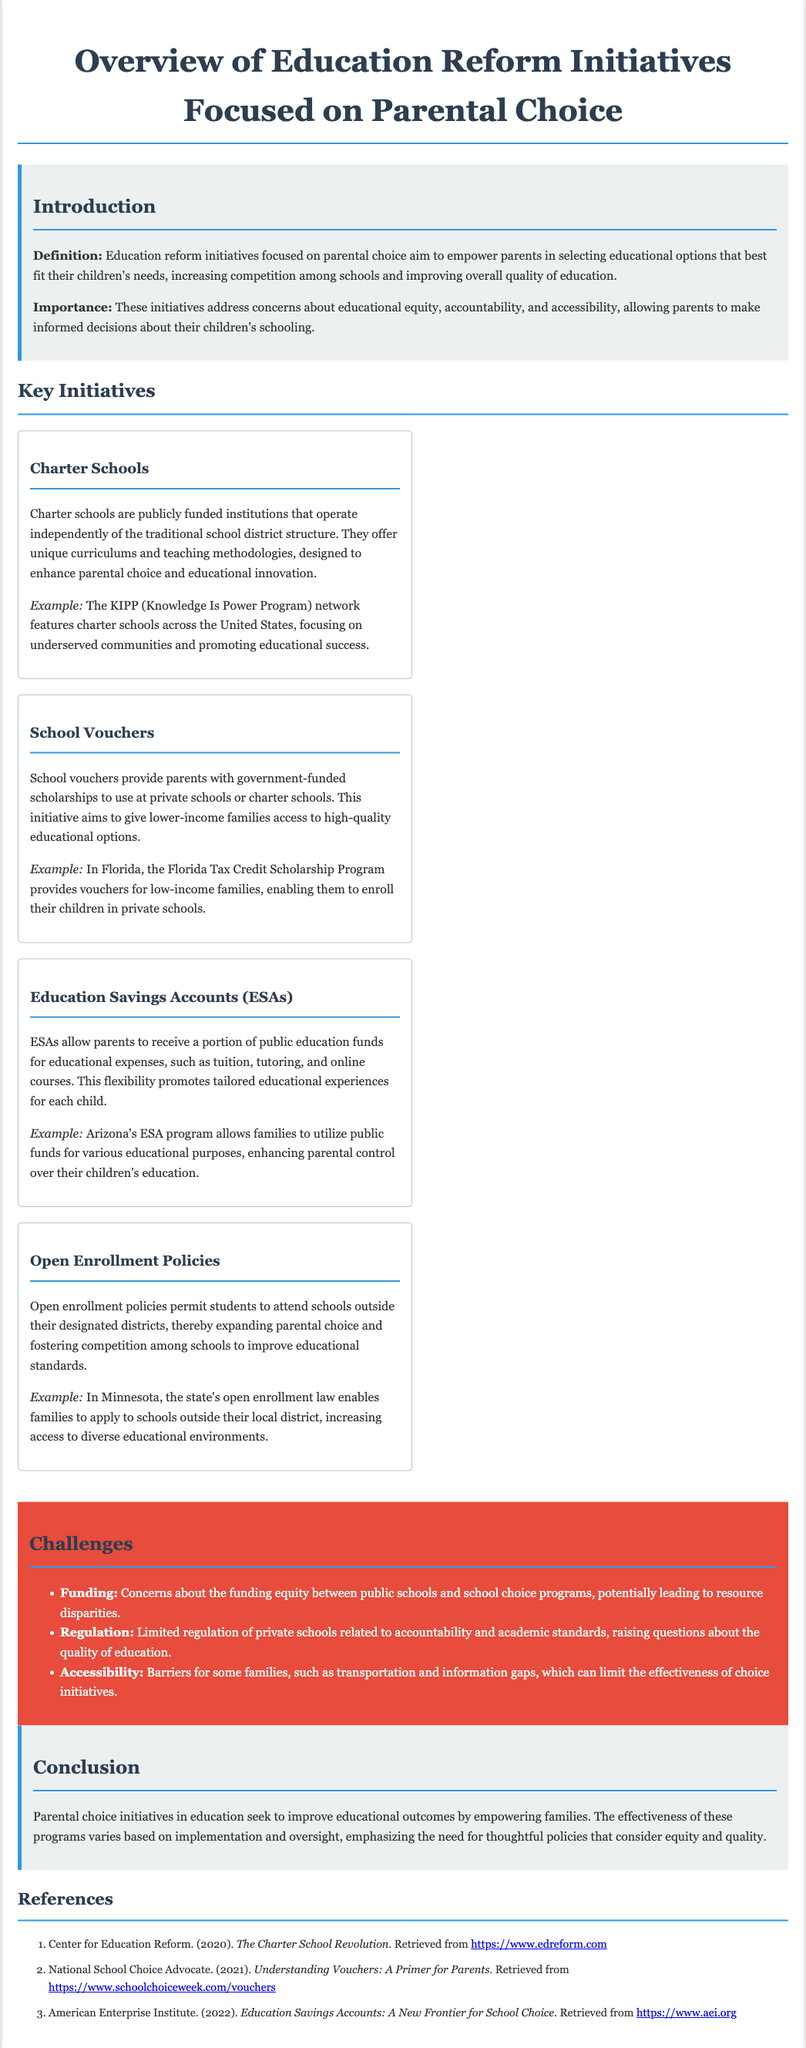what is the title of the document? The title is found in the <title> tag of the document.
Answer: Overview of Education Reform Initiatives Focused on Parental Choice what is the definition of education reform initiatives focused on parental choice? The definition is provided in the introduction section of the document.
Answer: Empower parents in selecting educational options what initiative provides government-funded scholarships for private schools? This initiative is mentioned under the Key Initiatives section.
Answer: School Vouchers which example of a charter school network is highlighted in the document? The relevant example is listed within the Charter Schools initiative description.
Answer: KIPP what challenge relates to educational resource disparities? This challenge is one of the listed challenges in the document.
Answer: Funding how does Arizona's ESA program enhance parental control? This is discussed in the Education Savings Accounts section of the document.
Answer: Allows families to utilize public funds what does the open enrollment policy permit? The open enrollment policy specifics are explained in the respective initiative section.
Answer: Attend schools outside their designated districts how many references are provided in the document? The number of references is counted in the References section.
Answer: Three 